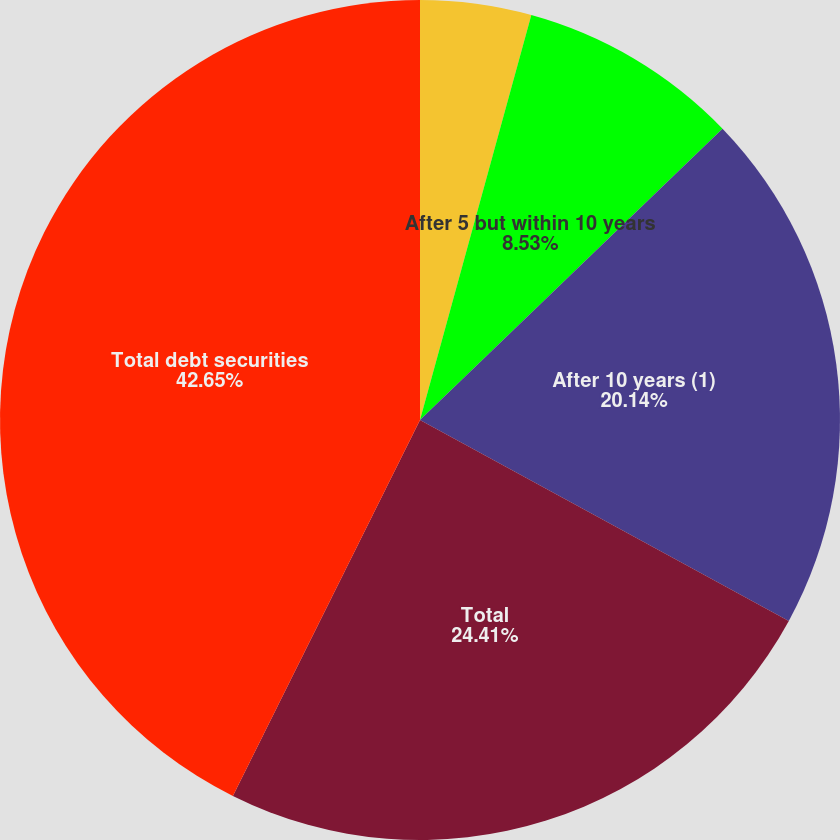Convert chart to OTSL. <chart><loc_0><loc_0><loc_500><loc_500><pie_chart><fcel>Due within 1 year<fcel>After 1 but within 5 years<fcel>After 5 but within 10 years<fcel>After 10 years (1)<fcel>Total<fcel>Total debt securities<nl><fcel>0.0%<fcel>4.27%<fcel>8.53%<fcel>20.14%<fcel>24.41%<fcel>42.65%<nl></chart> 